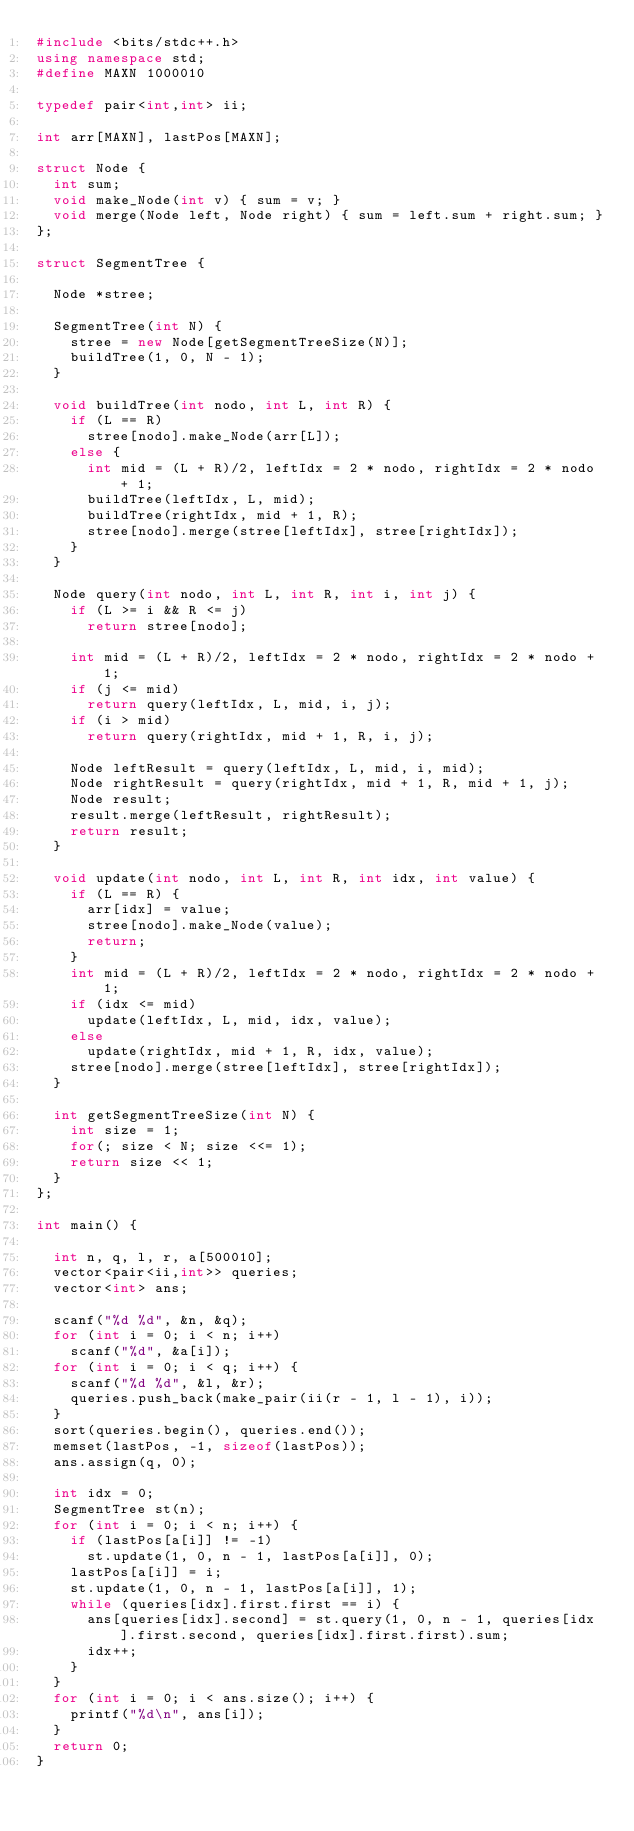Convert code to text. <code><loc_0><loc_0><loc_500><loc_500><_C++_>#include <bits/stdc++.h>
using namespace std;
#define MAXN 1000010
 
typedef pair<int,int> ii;
 
int arr[MAXN], lastPos[MAXN];
 
struct Node {
	int sum;
	void make_Node(int v) { sum = v; }
	void merge(Node left, Node right) { sum = left.sum + right.sum; }
};
 
struct SegmentTree {
	
	Node *stree;
 
	SegmentTree(int N) {
		stree = new Node[getSegmentTreeSize(N)];
		buildTree(1, 0, N - 1);
	}
 
	void buildTree(int nodo, int L, int R) {
		if (L == R)
			stree[nodo].make_Node(arr[L]);
		else {
			int mid = (L + R)/2, leftIdx = 2 * nodo, rightIdx = 2 * nodo + 1;
			buildTree(leftIdx, L, mid);
			buildTree(rightIdx, mid + 1, R);
			stree[nodo].merge(stree[leftIdx], stree[rightIdx]);
		}
	}
 
	Node query(int nodo, int L, int R, int i, int j) {
		if (L >= i && R <= j)
			return stree[nodo];
		
		int mid = (L + R)/2, leftIdx = 2 * nodo, rightIdx = 2 * nodo + 1;
		if (j <= mid)
			return query(leftIdx, L, mid, i, j);
		if (i > mid)
			return query(rightIdx, mid + 1, R, i, j);
		
		Node leftResult = query(leftIdx, L, mid, i, mid);
		Node rightResult = query(rightIdx, mid + 1, R, mid + 1, j);
		Node result;
		result.merge(leftResult, rightResult);
		return result;
	}
 
	void update(int nodo, int L, int R, int idx, int value) {
		if (L == R) {
			arr[idx] = value;
			stree[nodo].make_Node(value);
			return;
		}
		int mid = (L + R)/2, leftIdx = 2 * nodo, rightIdx = 2 * nodo + 1;
		if (idx <= mid)
			update(leftIdx, L, mid, idx, value);
		else
			update(rightIdx, mid + 1, R, idx, value);
		stree[nodo].merge(stree[leftIdx], stree[rightIdx]);
	}
 
	int getSegmentTreeSize(int N) {
		int size = 1;
		for(; size < N; size <<= 1);
		return size << 1;
	}
};
 
int main() {
	
	int n, q, l, r, a[500010];
	vector<pair<ii,int>> queries;
	vector<int> ans;
 
	scanf("%d %d", &n, &q);
	for (int i = 0; i < n; i++)
		scanf("%d", &a[i]);
	for (int i = 0; i < q; i++) {
		scanf("%d %d", &l, &r);
		queries.push_back(make_pair(ii(r - 1, l - 1), i));
	}
	sort(queries.begin(), queries.end());
	memset(lastPos, -1, sizeof(lastPos));
	ans.assign(q, 0);
 
	int idx = 0;
	SegmentTree st(n);
	for (int i = 0; i < n; i++) {
		if (lastPos[a[i]] != -1)
			st.update(1, 0, n - 1, lastPos[a[i]], 0);
		lastPos[a[i]] = i;
		st.update(1, 0, n - 1, lastPos[a[i]], 1);
		while (queries[idx].first.first == i) {
			ans[queries[idx].second] = st.query(1, 0, n - 1, queries[idx].first.second, queries[idx].first.first).sum;
			idx++;
		}
	}
	for (int i = 0; i < ans.size(); i++) {
		printf("%d\n", ans[i]);
	}
	return 0;
}</code> 